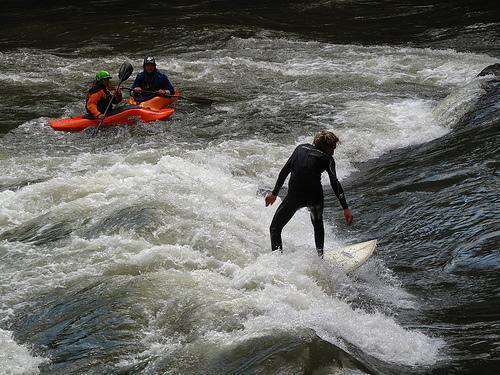How many people in the boats?
Give a very brief answer. 2. How many people are pictured?
Give a very brief answer. 3. 